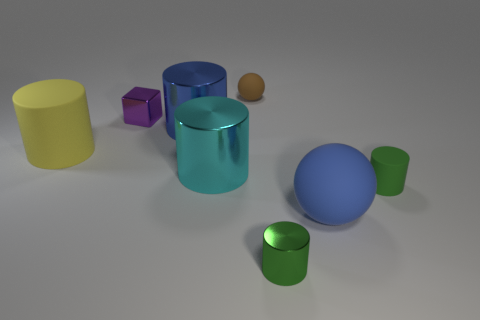Subtract 2 cylinders. How many cylinders are left? 3 Subtract all blue cylinders. How many cylinders are left? 4 Subtract all red cylinders. Subtract all red balls. How many cylinders are left? 5 Add 2 brown rubber things. How many objects exist? 10 Subtract all cylinders. How many objects are left? 3 Add 2 purple objects. How many purple objects exist? 3 Subtract 1 brown spheres. How many objects are left? 7 Subtract all blue blocks. Subtract all small purple metal things. How many objects are left? 7 Add 2 large blue things. How many large blue things are left? 4 